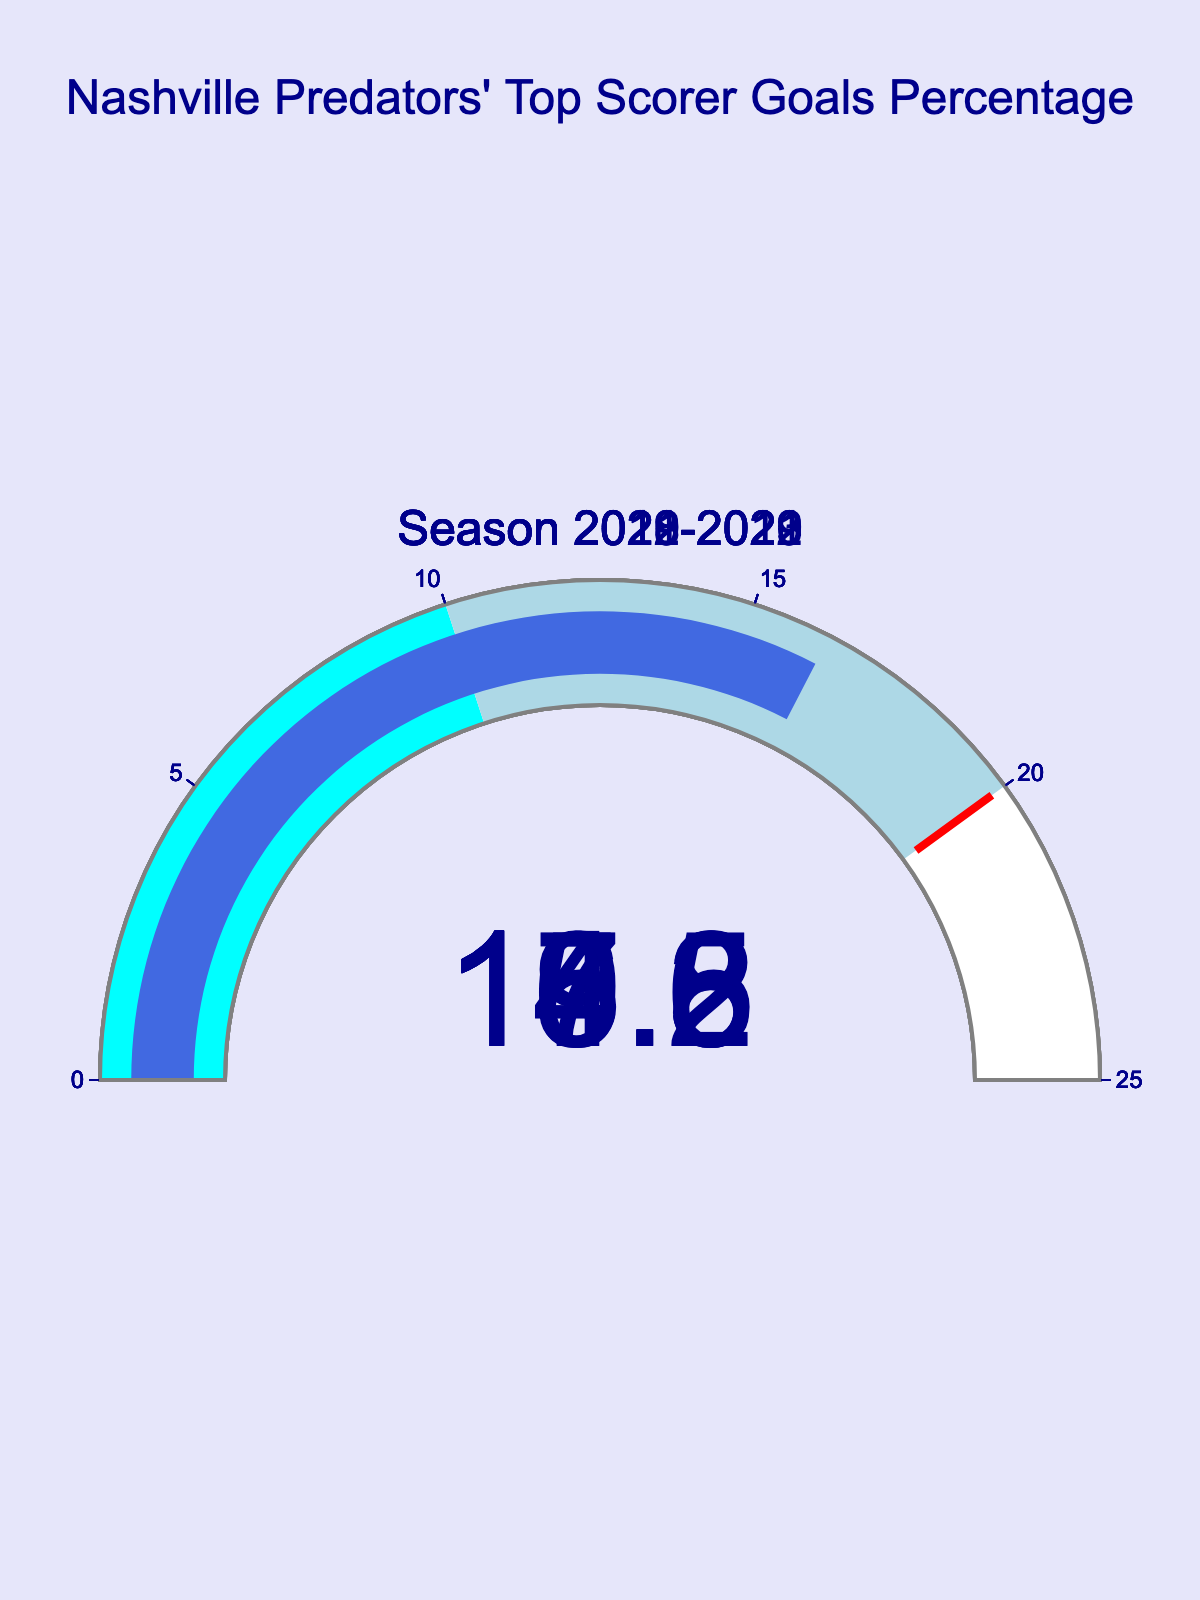What's the title of the figure? The title of the figure is displayed at the top center and reads "Nashville Predators' Top Scorer Goals Percentage".
Answer: Nashville Predators' Top Scorer Goals Percentage How many seasons are represented in this gauge chart? The gauge chart displays one number for each season on a separate gauge, representing five distinct seasons.
Answer: Five What is the percentage of goals scored by the top scorer in the 2020-2021 season? By looking at the gauge labeled "Season 2020-2021," the displayed number indicates the percentage.
Answer: 19.5 Which season has the highest percentage of goals scored by the top scorer? By comparing the values shown on each gauge, the 2020-2021 season has the highest indicated percentage.
Answer: 2020-2021 Which two seasons have the most similar percentages of goals scored by the top scorer? Comparing all the percentages, the 2018-2019 season (16.3%) and the 2021-2022 season (15.8%) are closest to each other.
Answer: 2018-2019 and 2021-2022 Is there any season where the percentage exceeds the 20% threshold? Inspecting the thresholds on the gauges, none of the displayed values exceed 20%.
Answer: No Which season shows the lowest percentage of goals scored by the top scorer, and what is that percentage? The gauge for the 2019-2020 season shows the lowest value.
Answer: 2019-2020, 14.6 In how many seasons did the top scorer contribute to more than 15% but less than 20% of the goals? The seasons are examined to count how many fall within this range: 2022-2023 (17.2), 2021-2022 (15.8), 2020-2021 (19.5), and 2018-2019 (16.3).
Answer: Four 